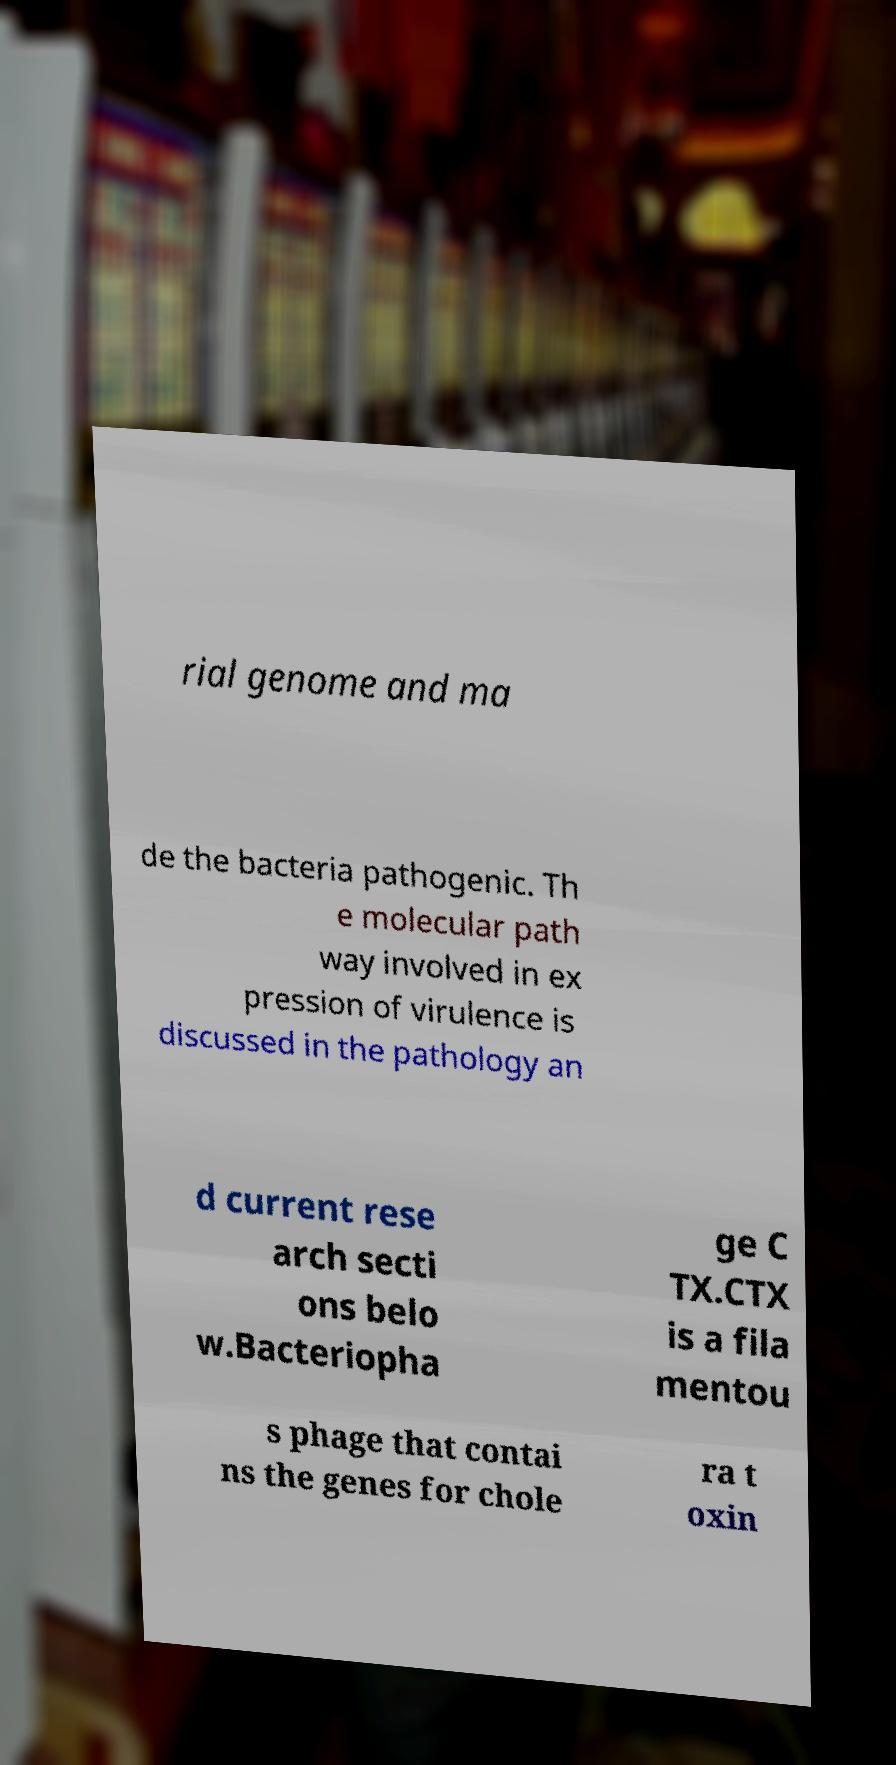What messages or text are displayed in this image? I need them in a readable, typed format. rial genome and ma de the bacteria pathogenic. Th e molecular path way involved in ex pression of virulence is discussed in the pathology an d current rese arch secti ons belo w.Bacteriopha ge C TX.CTX is a fila mentou s phage that contai ns the genes for chole ra t oxin 